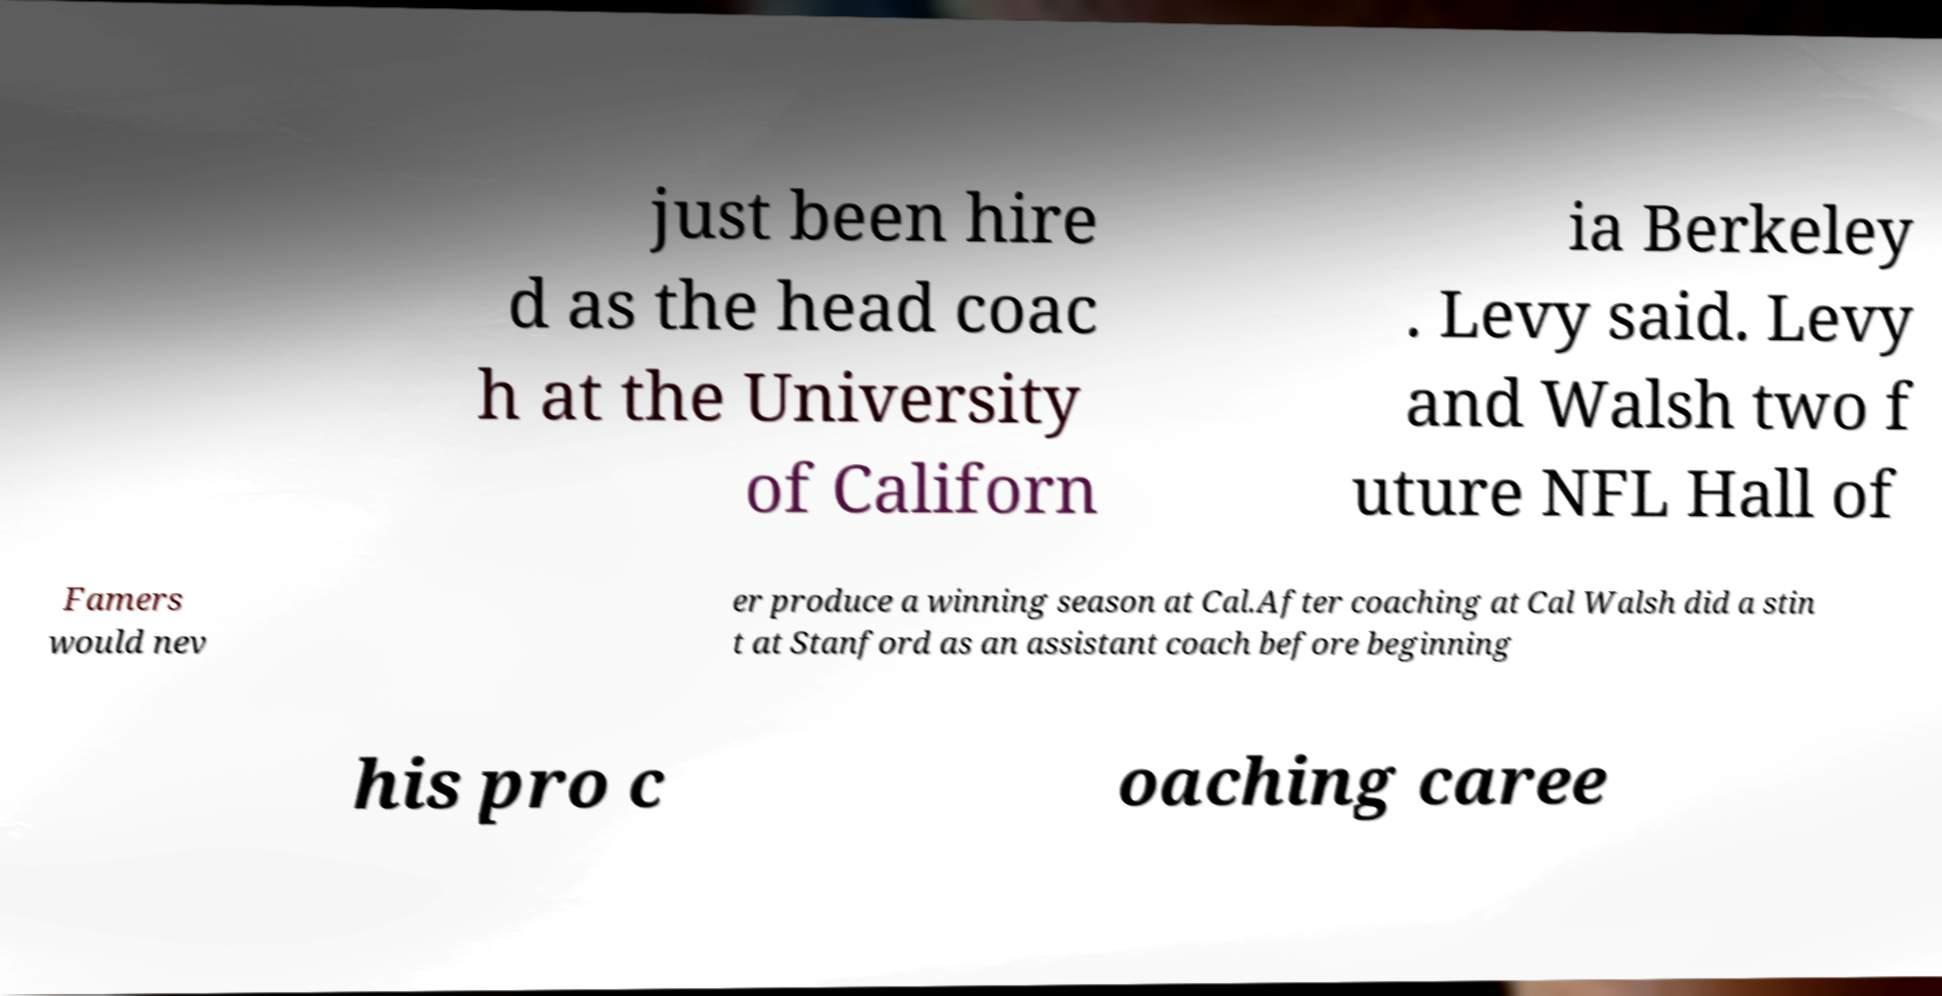Could you assist in decoding the text presented in this image and type it out clearly? just been hire d as the head coac h at the University of Californ ia Berkeley . Levy said. Levy and Walsh two f uture NFL Hall of Famers would nev er produce a winning season at Cal.After coaching at Cal Walsh did a stin t at Stanford as an assistant coach before beginning his pro c oaching caree 